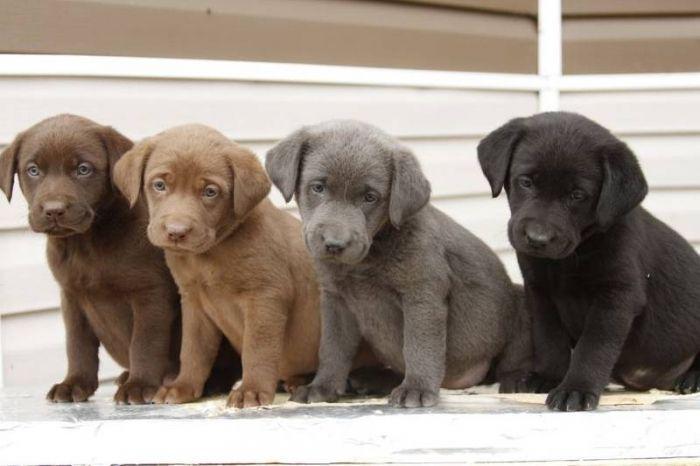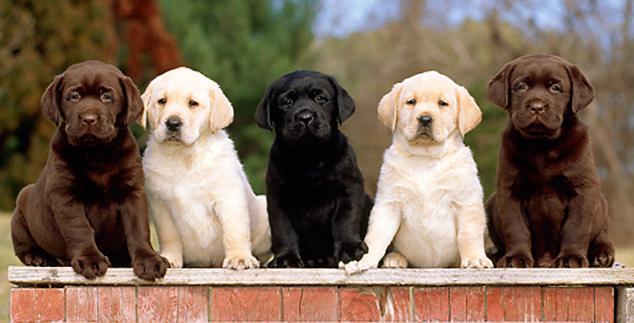The first image is the image on the left, the second image is the image on the right. Given the left and right images, does the statement "There are five puppies in the image pair." hold true? Answer yes or no. No. The first image is the image on the left, the second image is the image on the right. Evaluate the accuracy of this statement regarding the images: "There are no more than two dogs in the right image.". Is it true? Answer yes or no. No. 